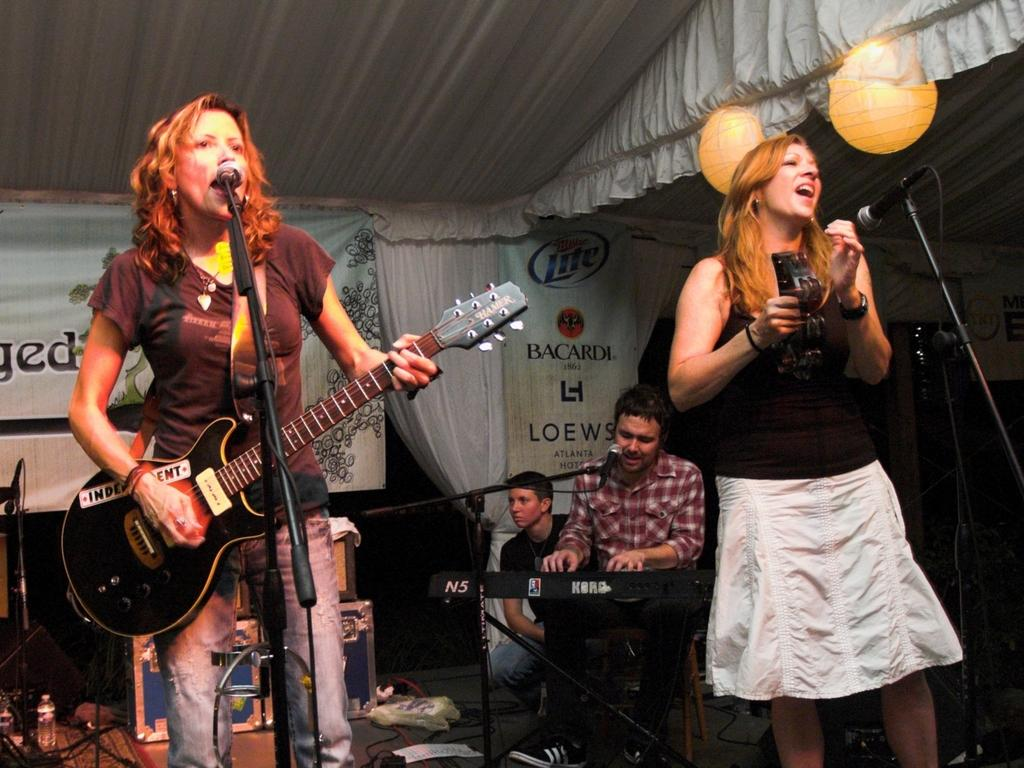What are the women in the image doing? The women are playing musical instruments and singing. What can be seen in front of the women? The women are in front of a microphone. What is the man in the image doing? The man is playing a piano and singing. What is in front of the man? The man is in front of a microphone. What is hanging on the curtain in the image? There is a banner on a curtain. What else can be seen in the image besides the people and the banner? There are boxes present. What type of fear can be seen on the faces of the women in the image? There is no indication of fear on the faces of the women in the image; they appear to be enjoying themselves while playing and singing. What request is the man making to the audience in the image? There is no indication of a request being made by the man in the image; he is simply playing the piano and singing. 